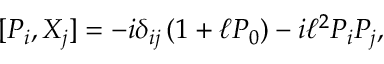Convert formula to latex. <formula><loc_0><loc_0><loc_500><loc_500>[ P _ { i } , { X } _ { j } ] = - i \delta _ { i j } \left ( 1 + \ell P _ { 0 } \right ) - i \ell ^ { 2 } P _ { i } P _ { j } ,</formula> 